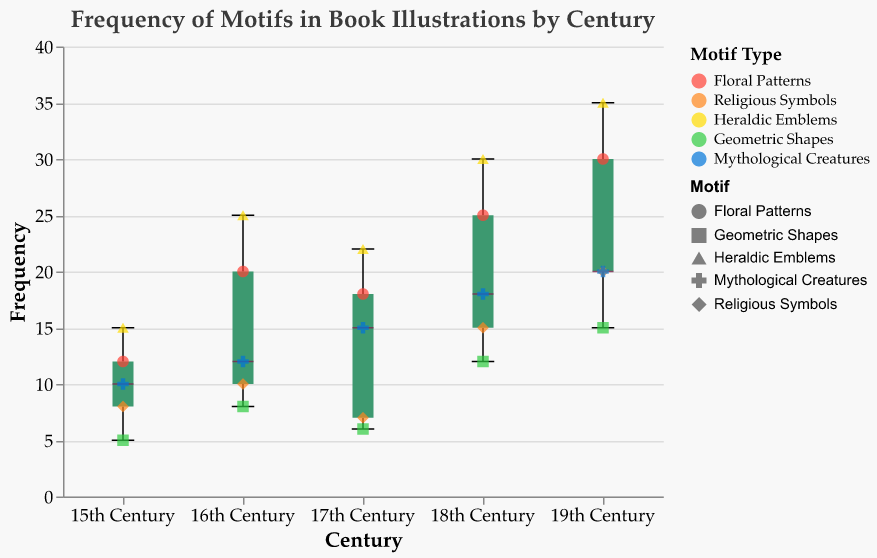What is the title of the figure? The title can be found at the top of the figure. It reads "Frequency of Motifs in Book Illustrations by Century."
Answer: Frequency of Motifs in Book Illustrations by Century What is the frequency range for motifs in the 19th century? The frequency range can be determined by looking at the boxplot for the 19th century. The minimum value is 15 (Geometric Shapes), and the maximum value is 35 (Heraldic Emblems).
Answer: 15 to 35 Which motif has the highest frequency in the 15th century? The scatter points will help identify the specific motif frequencies. The highest frequency in the 15th century is 15, corresponding to Heraldic Emblems.
Answer: Heraldic Emblems Which century has the highest median frequency of motifs? The median frequency is indicated by the line inside the boxplot. The 19th century shows the highest median frequency compared to other centuries.
Answer: 19th century What is the median frequency of motifs in the 16th century? The median value is represented by the line within the box of the boxplot for the 16th century. The line shows a median value of around 12.
Answer: 12 How do the frequencies of Geometric Shapes vary across centuries? By looking at the scatter points for each century, we can observe the frequencies of Geometric Shapes: 5 (15th), 8 (16th), 6 (17th), 12 (18th), and 15 (19th).
Answer: 5, 8, 6, 12, 15 Compare the range of frequencies for motifs in the 17th century and the 18th century. The 17th century ranges from 6 to 22, while the 18th century ranges from 12 to 30. The 18th-century range is wider.
Answer: The 18th century has a wider range Which motif consistently shows a trend of increasing frequency over the centuries? By following the scatter points of each motif across centuries, Floral Patterns show an increasing trend: 12 (15th), 20 (16th), 18 (17th), 25 (18th), 30 (19th).
Answer: Floral Patterns Which century has the smallest interquartile range (IQR) for motif frequencies? The IQR is indicated by the box length in each boxplot. The century with the smallest IQR appears to be the 17th century as indicated by the shortest box length.
Answer: 17th century 